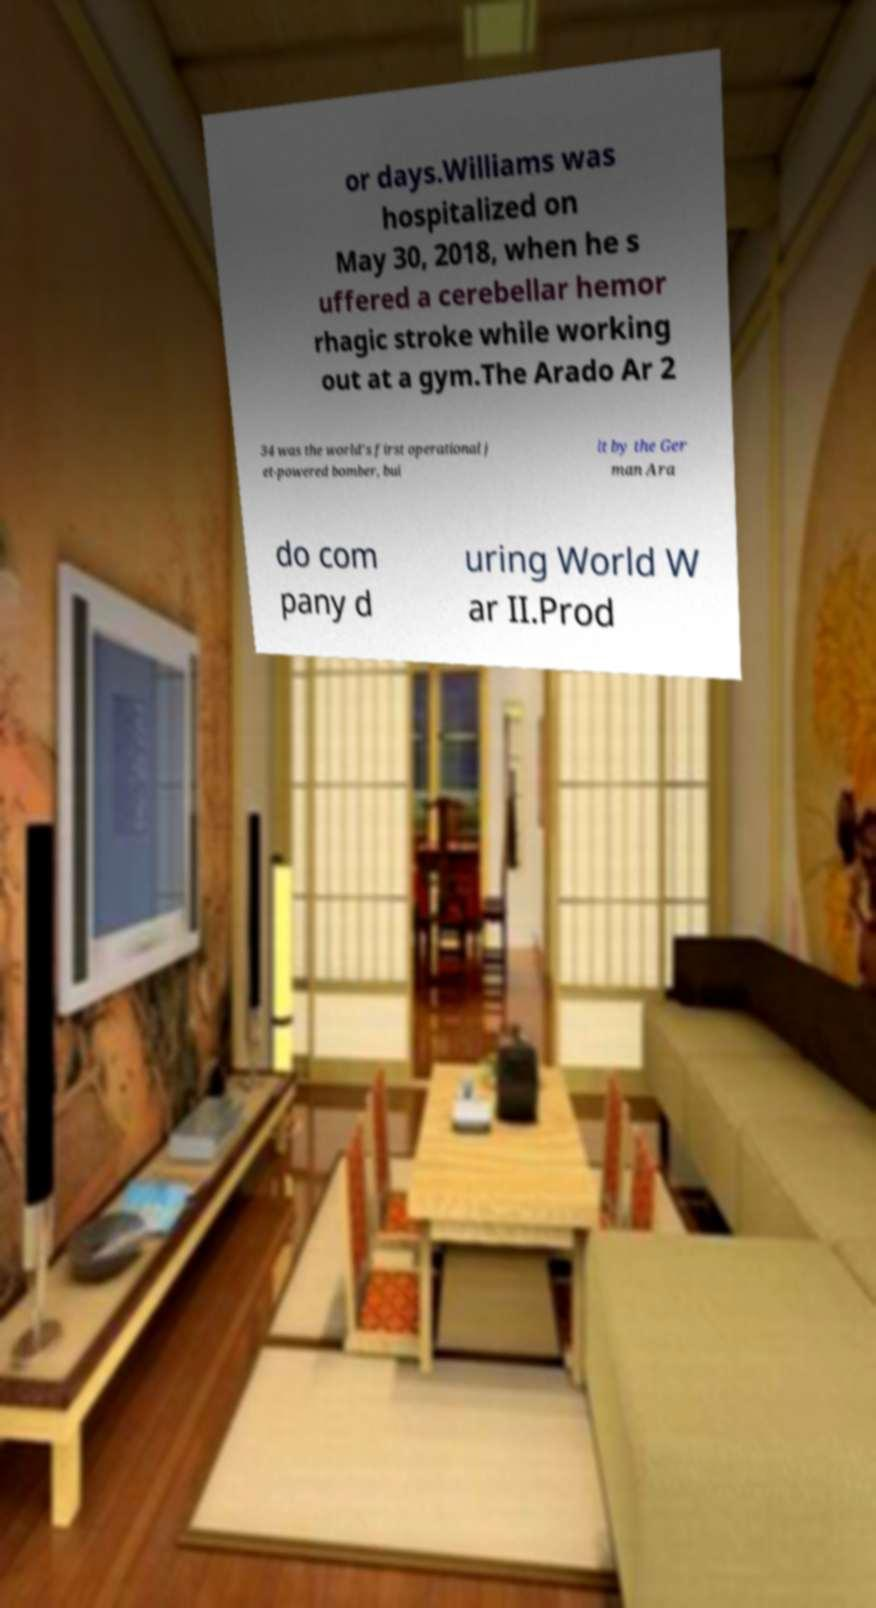Can you accurately transcribe the text from the provided image for me? or days.Williams was hospitalized on May 30, 2018, when he s uffered a cerebellar hemor rhagic stroke while working out at a gym.The Arado Ar 2 34 was the world's first operational j et-powered bomber, bui lt by the Ger man Ara do com pany d uring World W ar II.Prod 